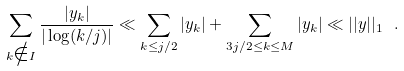Convert formula to latex. <formula><loc_0><loc_0><loc_500><loc_500>\sum _ { k \notin I } \frac { | y _ { k } | } { | \log ( k / j ) | } \ll \sum _ { k \leq j / 2 } | y _ { k } | + \sum _ { 3 j / 2 \leq k \leq M } | y _ { k } | \ll | | { y } | | _ { 1 } \ .</formula> 